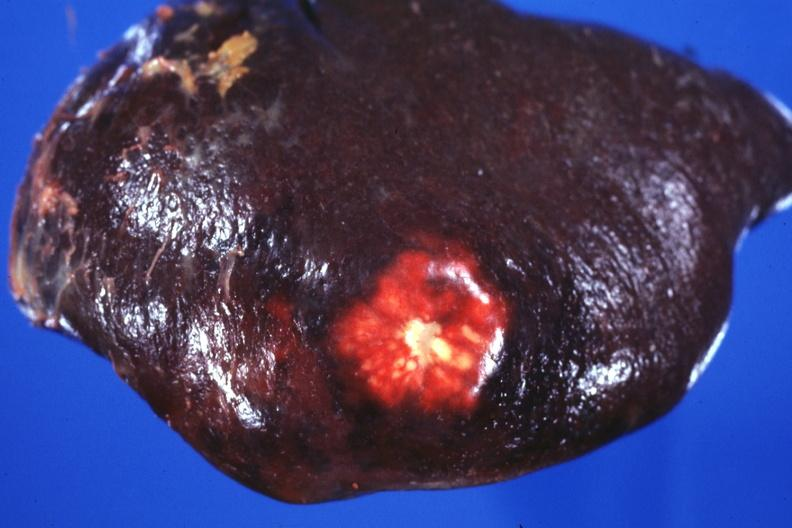does benign cystic teratoma show external view of spleen with obvious metastatic nodule beneath capsule?
Answer the question using a single word or phrase. No 